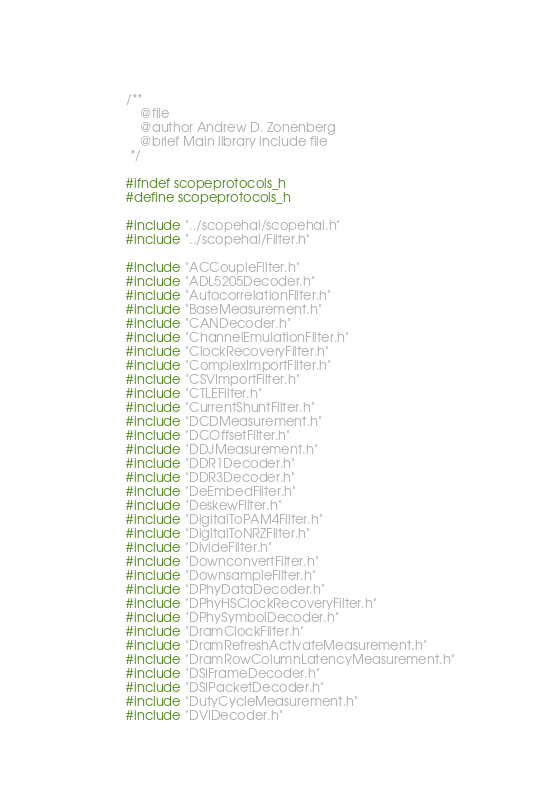<code> <loc_0><loc_0><loc_500><loc_500><_C_>/**
	@file
	@author Andrew D. Zonenberg
	@brief Main library include file
 */

#ifndef scopeprotocols_h
#define scopeprotocols_h

#include "../scopehal/scopehal.h"
#include "../scopehal/Filter.h"

#include "ACCoupleFilter.h"
#include "ADL5205Decoder.h"
#include "AutocorrelationFilter.h"
#include "BaseMeasurement.h"
#include "CANDecoder.h"
#include "ChannelEmulationFilter.h"
#include "ClockRecoveryFilter.h"
#include "ComplexImportFilter.h"
#include "CSVImportFilter.h"
#include "CTLEFilter.h"
#include "CurrentShuntFilter.h"
#include "DCDMeasurement.h"
#include "DCOffsetFilter.h"
#include "DDJMeasurement.h"
#include "DDR1Decoder.h"
#include "DDR3Decoder.h"
#include "DeEmbedFilter.h"
#include "DeskewFilter.h"
#include "DigitalToPAM4Filter.h"
#include "DigitalToNRZFilter.h"
#include "DivideFilter.h"
#include "DownconvertFilter.h"
#include "DownsampleFilter.h"
#include "DPhyDataDecoder.h"
#include "DPhyHSClockRecoveryFilter.h"
#include "DPhySymbolDecoder.h"
#include "DramClockFilter.h"
#include "DramRefreshActivateMeasurement.h"
#include "DramRowColumnLatencyMeasurement.h"
#include "DSIFrameDecoder.h"
#include "DSIPacketDecoder.h"
#include "DutyCycleMeasurement.h"
#include "DVIDecoder.h"</code> 